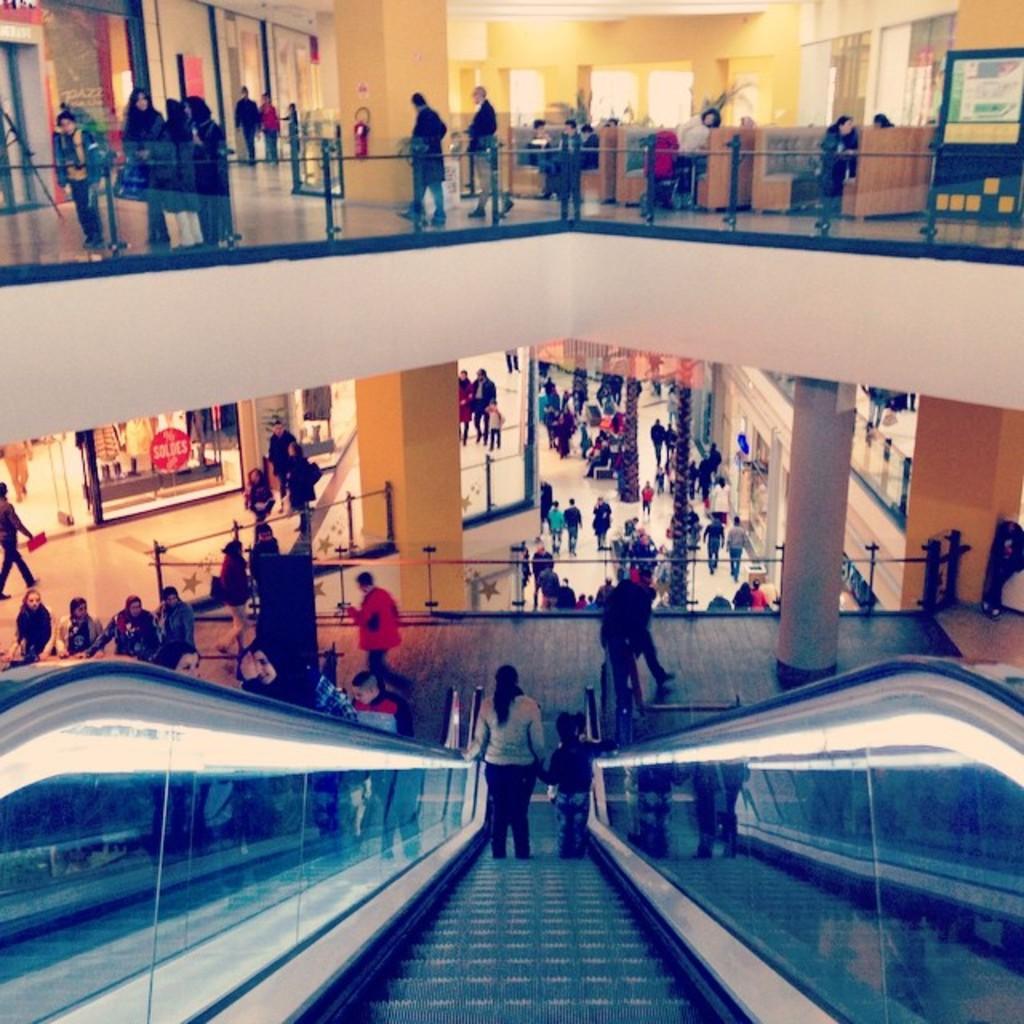Could you give a brief overview of what you see in this image? In this picture we can observe an escalator. There are some members walking in this building. We can observe glass railing. There are some pillars. In the background we can observe yellow color wall. 